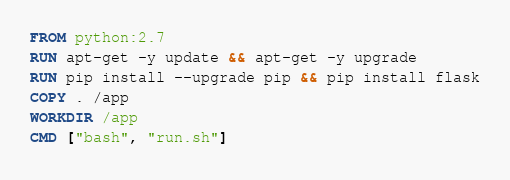<code> <loc_0><loc_0><loc_500><loc_500><_Dockerfile_>FROM python:2.7
RUN apt-get -y update && apt-get -y upgrade
RUN pip install --upgrade pip && pip install flask
COPY . /app
WORKDIR /app
CMD ["bash", "run.sh"]
</code> 